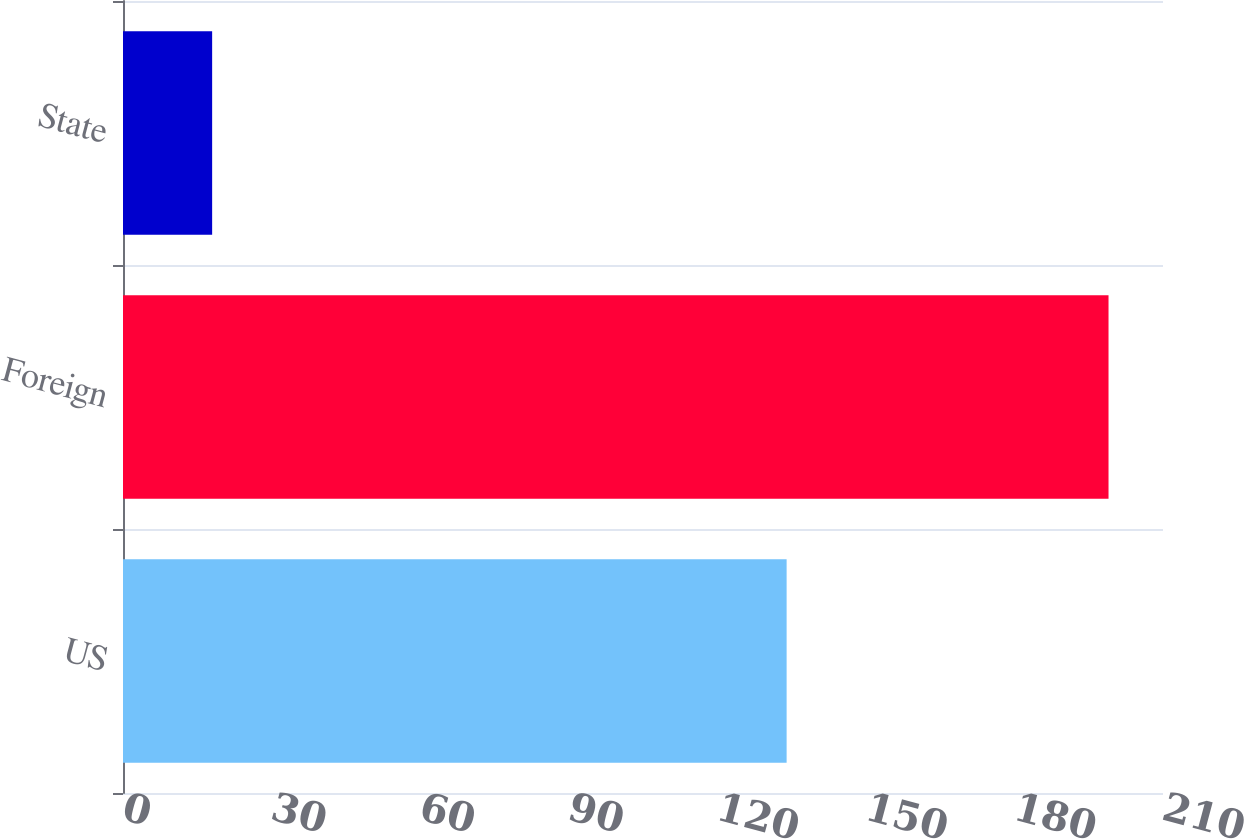Convert chart. <chart><loc_0><loc_0><loc_500><loc_500><bar_chart><fcel>US<fcel>Foreign<fcel>State<nl><fcel>134<fcel>199<fcel>18<nl></chart> 